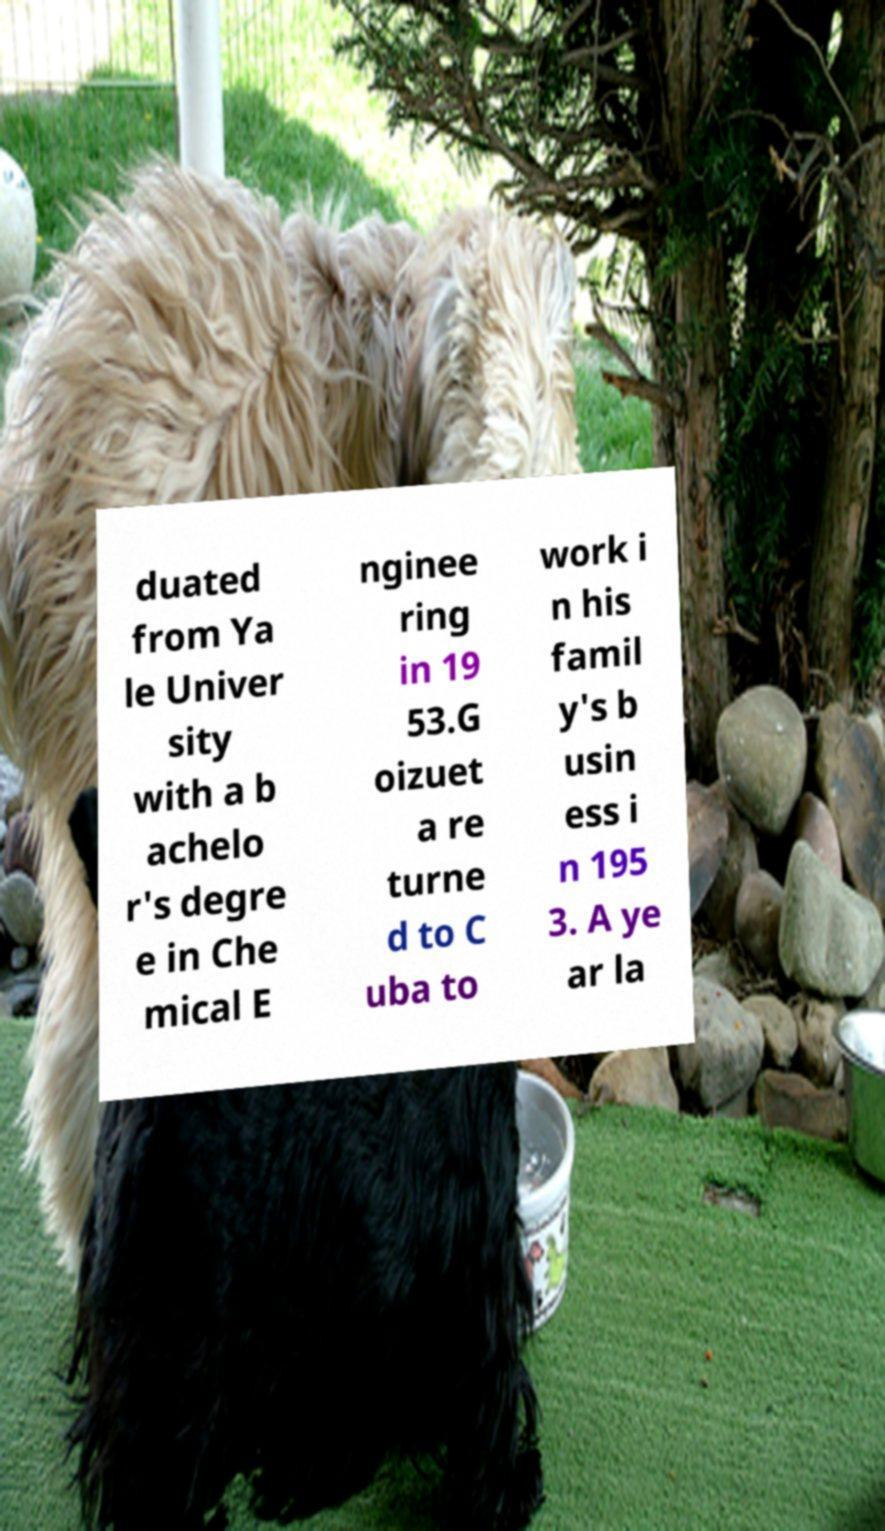For documentation purposes, I need the text within this image transcribed. Could you provide that? duated from Ya le Univer sity with a b achelo r's degre e in Che mical E nginee ring in 19 53.G oizuet a re turne d to C uba to work i n his famil y's b usin ess i n 195 3. A ye ar la 